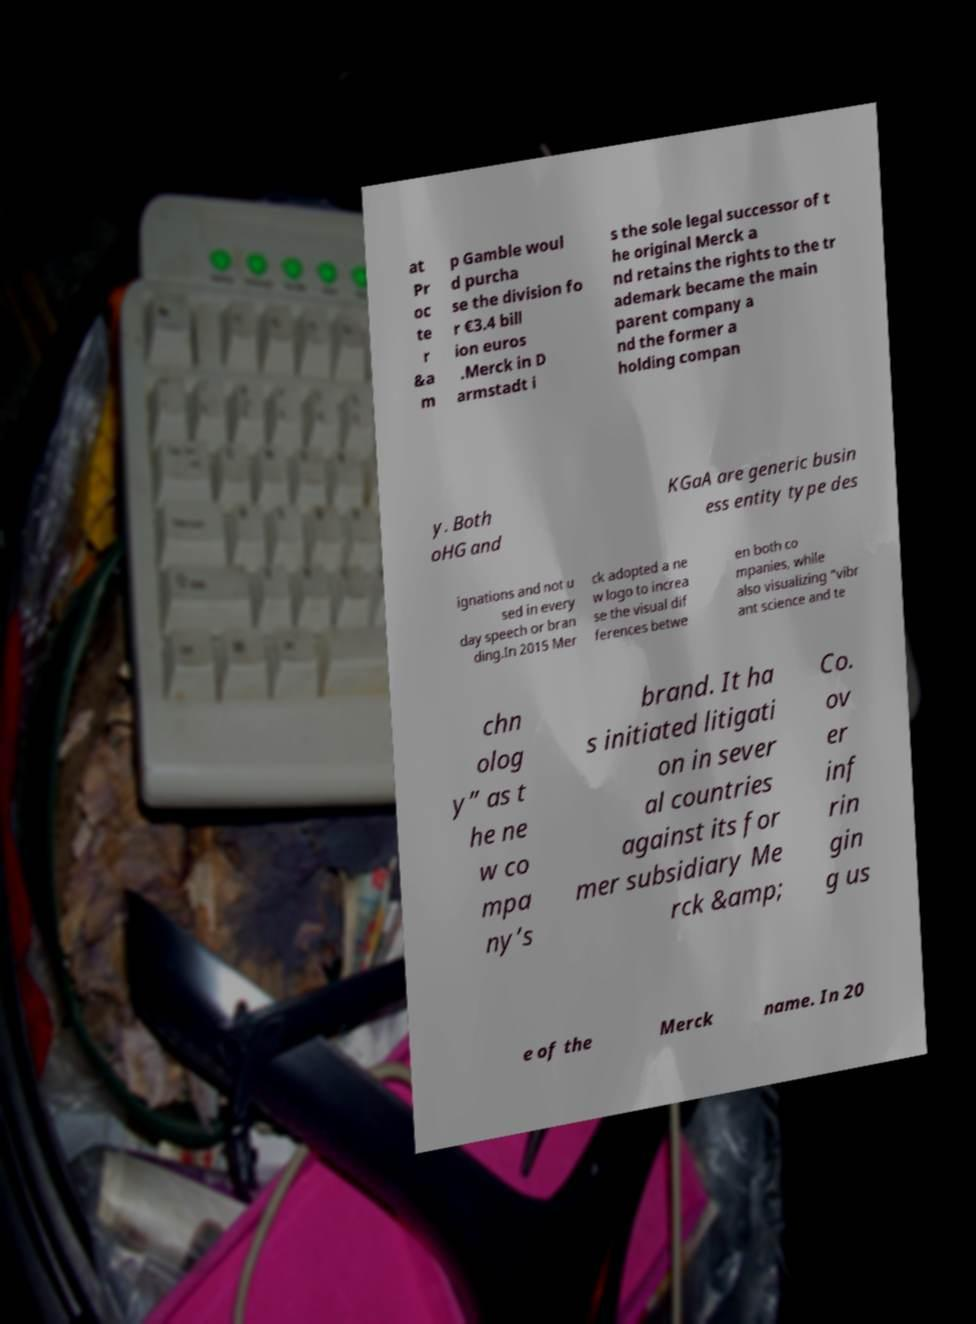For documentation purposes, I need the text within this image transcribed. Could you provide that? at Pr oc te r &a m p Gamble woul d purcha se the division fo r €3.4 bill ion euros .Merck in D armstadt i s the sole legal successor of t he original Merck a nd retains the rights to the tr ademark became the main parent company a nd the former a holding compan y. Both oHG and KGaA are generic busin ess entity type des ignations and not u sed in every day speech or bran ding.In 2015 Mer ck adopted a ne w logo to increa se the visual dif ferences betwe en both co mpanies, while also visualizing “vibr ant science and te chn olog y” as t he ne w co mpa ny’s brand. It ha s initiated litigati on in sever al countries against its for mer subsidiary Me rck &amp; Co. ov er inf rin gin g us e of the Merck name. In 20 